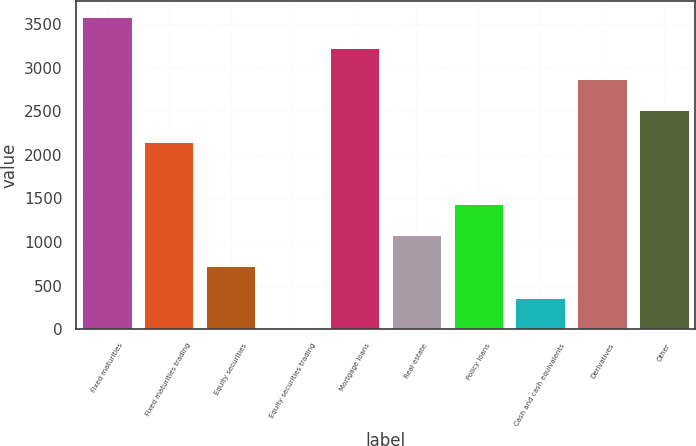Convert chart. <chart><loc_0><loc_0><loc_500><loc_500><bar_chart><fcel>Fixed maturities<fcel>Fixed maturities trading<fcel>Equity securities<fcel>Equity securities trading<fcel>Mortgage loans<fcel>Real estate<fcel>Policy loans<fcel>Cash and cash equivalents<fcel>Derivatives<fcel>Other<nl><fcel>3586<fcel>2152.72<fcel>719.44<fcel>2.8<fcel>3227.68<fcel>1077.76<fcel>1436.08<fcel>361.12<fcel>2869.36<fcel>2511.04<nl></chart> 